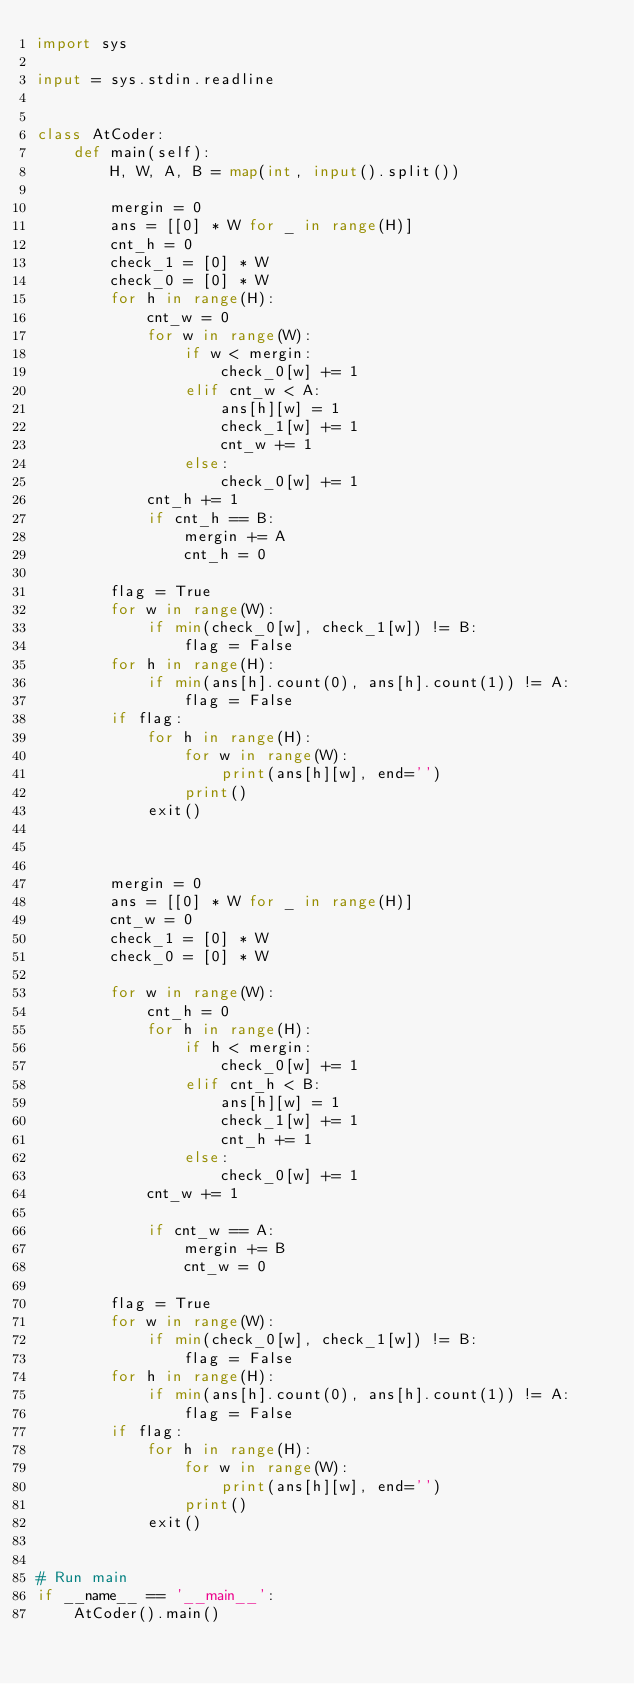<code> <loc_0><loc_0><loc_500><loc_500><_Python_>import sys

input = sys.stdin.readline


class AtCoder:
    def main(self):
        H, W, A, B = map(int, input().split())

        mergin = 0
        ans = [[0] * W for _ in range(H)]
        cnt_h = 0
        check_1 = [0] * W
        check_0 = [0] * W
        for h in range(H):
            cnt_w = 0
            for w in range(W):
                if w < mergin:
                    check_0[w] += 1
                elif cnt_w < A:
                    ans[h][w] = 1
                    check_1[w] += 1
                    cnt_w += 1
                else:
                    check_0[w] += 1
            cnt_h += 1
            if cnt_h == B:
                mergin += A
                cnt_h = 0

        flag = True
        for w in range(W):
            if min(check_0[w], check_1[w]) != B:
                flag = False
        for h in range(H):
            if min(ans[h].count(0), ans[h].count(1)) != A:
                flag = False
        if flag:
            for h in range(H):
                for w in range(W):
                    print(ans[h][w], end='')
                print()
            exit()



        mergin = 0
        ans = [[0] * W for _ in range(H)]
        cnt_w = 0
        check_1 = [0] * W
        check_0 = [0] * W

        for w in range(W):
            cnt_h = 0
            for h in range(H):
                if h < mergin:
                    check_0[w] += 1
                elif cnt_h < B:
                    ans[h][w] = 1
                    check_1[w] += 1
                    cnt_h += 1
                else:
                    check_0[w] += 1
            cnt_w += 1

            if cnt_w == A:
                mergin += B
                cnt_w = 0

        flag = True
        for w in range(W):
            if min(check_0[w], check_1[w]) != B:
                flag = False
        for h in range(H):
            if min(ans[h].count(0), ans[h].count(1)) != A:
                flag = False
        if flag:
            for h in range(H):
                for w in range(W):
                    print(ans[h][w], end='')
                print()
            exit()


# Run main
if __name__ == '__main__':
    AtCoder().main()
</code> 